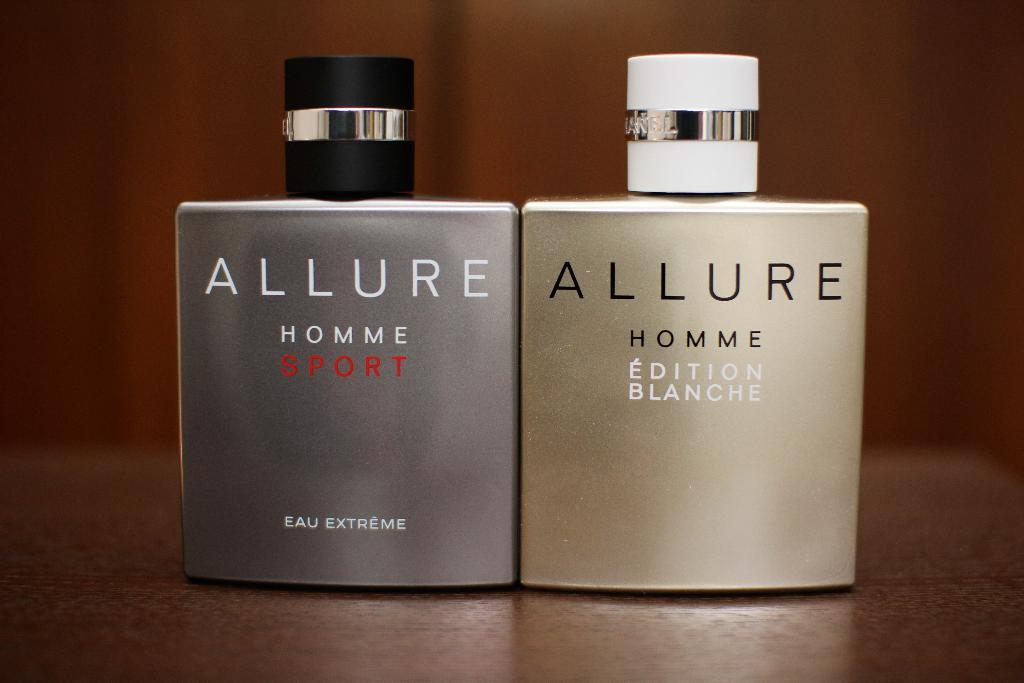<image>
Give a short and clear explanation of the subsequent image. Two Allure branded containers sit on a table. 